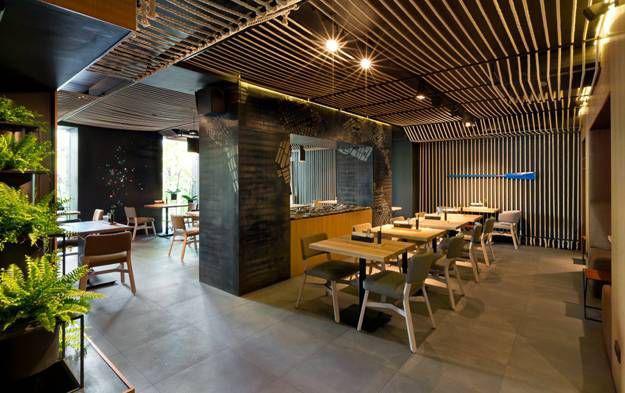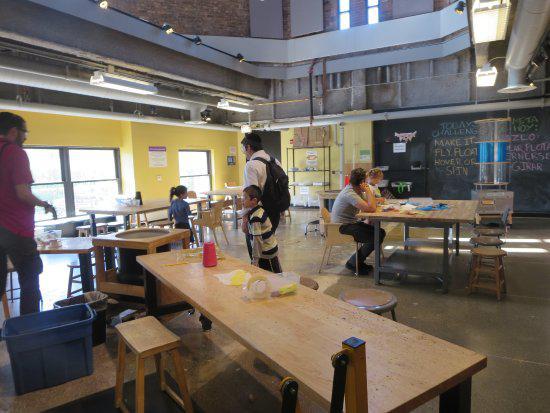The first image is the image on the left, the second image is the image on the right. Assess this claim about the two images: "The room in the right image has no people in it.". Correct or not? Answer yes or no. No. The first image is the image on the left, the second image is the image on the right. Given the left and right images, does the statement "Dome-shaped lights in rows suspend several feet from the ceiling over multiple seated customers in the left image." hold true? Answer yes or no. No. 